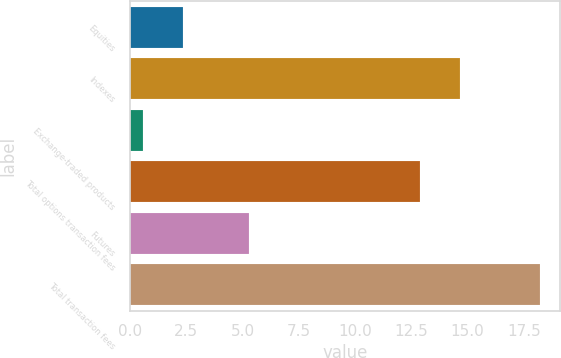<chart> <loc_0><loc_0><loc_500><loc_500><bar_chart><fcel>Equities<fcel>Indexes<fcel>Exchange-traded products<fcel>Total options transaction fees<fcel>Futures<fcel>Total transaction fees<nl><fcel>2.36<fcel>14.66<fcel>0.6<fcel>12.9<fcel>5.3<fcel>18.2<nl></chart> 